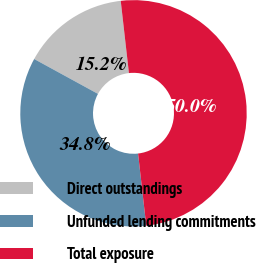<chart> <loc_0><loc_0><loc_500><loc_500><pie_chart><fcel>Direct outstandings<fcel>Unfunded lending commitments<fcel>Total exposure<nl><fcel>15.24%<fcel>34.76%<fcel>50.0%<nl></chart> 